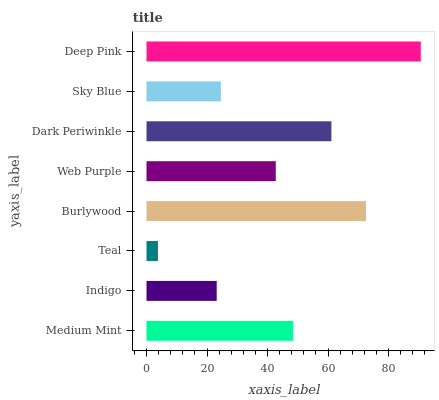Is Teal the minimum?
Answer yes or no. Yes. Is Deep Pink the maximum?
Answer yes or no. Yes. Is Indigo the minimum?
Answer yes or no. No. Is Indigo the maximum?
Answer yes or no. No. Is Medium Mint greater than Indigo?
Answer yes or no. Yes. Is Indigo less than Medium Mint?
Answer yes or no. Yes. Is Indigo greater than Medium Mint?
Answer yes or no. No. Is Medium Mint less than Indigo?
Answer yes or no. No. Is Medium Mint the high median?
Answer yes or no. Yes. Is Web Purple the low median?
Answer yes or no. Yes. Is Teal the high median?
Answer yes or no. No. Is Sky Blue the low median?
Answer yes or no. No. 